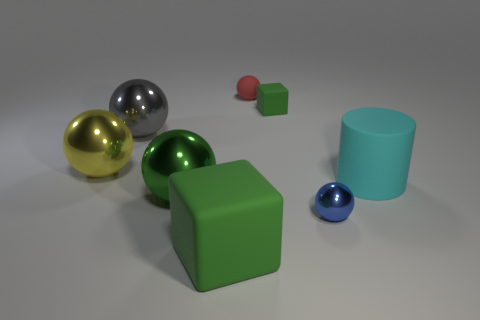The large rubber thing that is the same color as the small matte block is what shape?
Your answer should be compact. Cube. What number of large metal objects are on the right side of the yellow object?
Provide a short and direct response. 2. Do the matte block behind the yellow metallic ball and the big block have the same color?
Make the answer very short. Yes. What number of blue objects have the same size as the gray ball?
Ensure brevity in your answer.  0. There is a large green thing that is the same material as the cylinder; what is its shape?
Ensure brevity in your answer.  Cube. Are there any small objects that have the same color as the big block?
Offer a very short reply. Yes. What is the material of the red ball?
Your answer should be compact. Rubber. How many objects are either green cubes or small rubber spheres?
Provide a short and direct response. 3. There is a matte object behind the tiny matte cube; what is its size?
Give a very brief answer. Small. What number of other objects are there of the same material as the large block?
Your response must be concise. 3. 